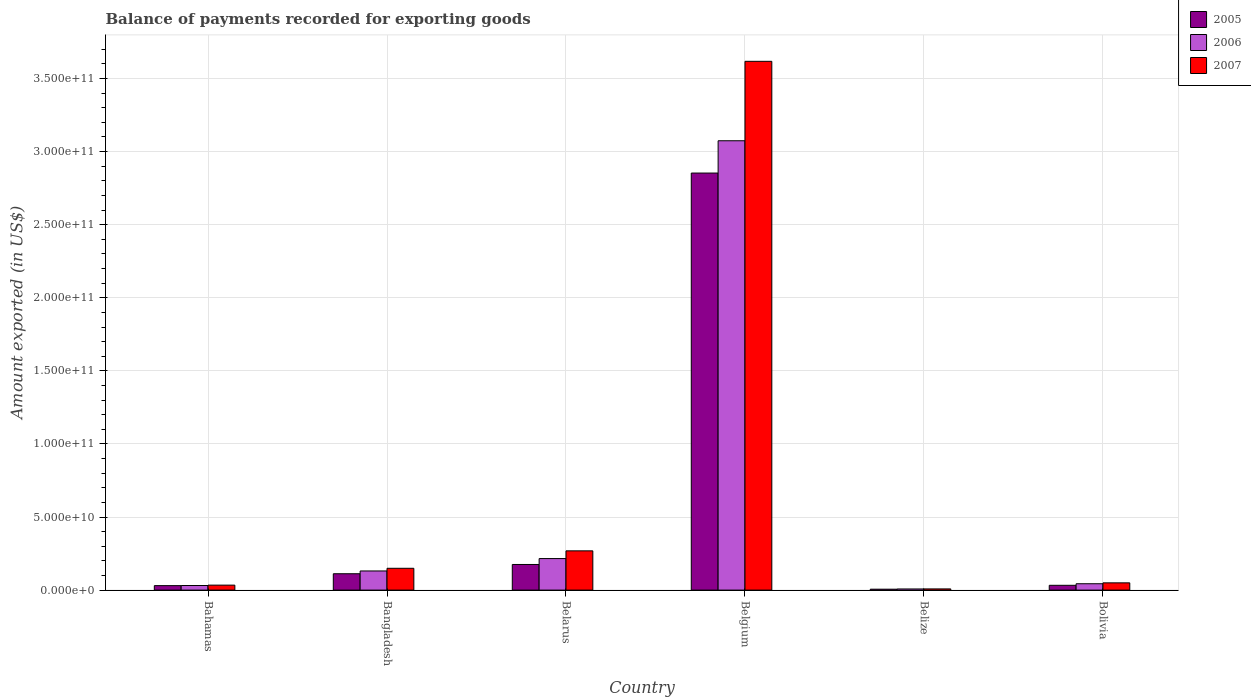How many different coloured bars are there?
Your answer should be very brief. 3. How many groups of bars are there?
Your response must be concise. 6. Are the number of bars per tick equal to the number of legend labels?
Your answer should be very brief. Yes. How many bars are there on the 6th tick from the left?
Ensure brevity in your answer.  3. What is the label of the 4th group of bars from the left?
Your answer should be compact. Belgium. In how many cases, is the number of bars for a given country not equal to the number of legend labels?
Offer a very short reply. 0. What is the amount exported in 2006 in Belize?
Ensure brevity in your answer.  7.76e+08. Across all countries, what is the maximum amount exported in 2007?
Offer a very short reply. 3.62e+11. Across all countries, what is the minimum amount exported in 2005?
Make the answer very short. 6.15e+08. In which country was the amount exported in 2006 maximum?
Offer a terse response. Belgium. In which country was the amount exported in 2006 minimum?
Your answer should be very brief. Belize. What is the total amount exported in 2007 in the graph?
Provide a short and direct response. 4.13e+11. What is the difference between the amount exported in 2005 in Belarus and that in Belgium?
Your answer should be very brief. -2.68e+11. What is the difference between the amount exported in 2006 in Bahamas and the amount exported in 2005 in Belarus?
Provide a succinct answer. -1.44e+1. What is the average amount exported in 2007 per country?
Ensure brevity in your answer.  6.88e+1. What is the difference between the amount exported of/in 2006 and amount exported of/in 2007 in Belgium?
Give a very brief answer. -5.44e+1. What is the ratio of the amount exported in 2006 in Bahamas to that in Belarus?
Your response must be concise. 0.15. What is the difference between the highest and the second highest amount exported in 2006?
Make the answer very short. 2.86e+11. What is the difference between the highest and the lowest amount exported in 2006?
Provide a short and direct response. 3.07e+11. In how many countries, is the amount exported in 2006 greater than the average amount exported in 2006 taken over all countries?
Offer a terse response. 1. Is the sum of the amount exported in 2006 in Belarus and Belize greater than the maximum amount exported in 2007 across all countries?
Provide a short and direct response. No. What does the 3rd bar from the left in Bolivia represents?
Make the answer very short. 2007. Is it the case that in every country, the sum of the amount exported in 2005 and amount exported in 2007 is greater than the amount exported in 2006?
Make the answer very short. Yes. Are all the bars in the graph horizontal?
Ensure brevity in your answer.  No. Are the values on the major ticks of Y-axis written in scientific E-notation?
Your response must be concise. Yes. Where does the legend appear in the graph?
Offer a very short reply. Top right. How many legend labels are there?
Offer a very short reply. 3. How are the legend labels stacked?
Ensure brevity in your answer.  Vertical. What is the title of the graph?
Your response must be concise. Balance of payments recorded for exporting goods. What is the label or title of the Y-axis?
Give a very brief answer. Amount exported (in US$). What is the Amount exported (in US$) in 2005 in Bahamas?
Offer a very short reply. 3.06e+09. What is the Amount exported (in US$) in 2006 in Bahamas?
Offer a terse response. 3.14e+09. What is the Amount exported (in US$) of 2007 in Bahamas?
Your answer should be compact. 3.40e+09. What is the Amount exported (in US$) in 2005 in Bangladesh?
Make the answer very short. 1.12e+1. What is the Amount exported (in US$) of 2006 in Bangladesh?
Provide a succinct answer. 1.31e+1. What is the Amount exported (in US$) of 2007 in Bangladesh?
Make the answer very short. 1.49e+1. What is the Amount exported (in US$) in 2005 in Belarus?
Your answer should be compact. 1.75e+1. What is the Amount exported (in US$) of 2006 in Belarus?
Offer a terse response. 2.16e+1. What is the Amount exported (in US$) of 2007 in Belarus?
Provide a short and direct response. 2.69e+1. What is the Amount exported (in US$) in 2005 in Belgium?
Ensure brevity in your answer.  2.85e+11. What is the Amount exported (in US$) in 2006 in Belgium?
Provide a short and direct response. 3.07e+11. What is the Amount exported (in US$) in 2007 in Belgium?
Offer a terse response. 3.62e+11. What is the Amount exported (in US$) in 2005 in Belize?
Provide a short and direct response. 6.15e+08. What is the Amount exported (in US$) of 2006 in Belize?
Provide a succinct answer. 7.76e+08. What is the Amount exported (in US$) in 2007 in Belize?
Your answer should be very brief. 8.16e+08. What is the Amount exported (in US$) of 2005 in Bolivia?
Provide a short and direct response. 3.28e+09. What is the Amount exported (in US$) of 2006 in Bolivia?
Provide a succinct answer. 4.35e+09. What is the Amount exported (in US$) in 2007 in Bolivia?
Your answer should be compact. 4.95e+09. Across all countries, what is the maximum Amount exported (in US$) of 2005?
Your answer should be compact. 2.85e+11. Across all countries, what is the maximum Amount exported (in US$) of 2006?
Ensure brevity in your answer.  3.07e+11. Across all countries, what is the maximum Amount exported (in US$) of 2007?
Offer a very short reply. 3.62e+11. Across all countries, what is the minimum Amount exported (in US$) of 2005?
Your response must be concise. 6.15e+08. Across all countries, what is the minimum Amount exported (in US$) of 2006?
Make the answer very short. 7.76e+08. Across all countries, what is the minimum Amount exported (in US$) of 2007?
Your answer should be very brief. 8.16e+08. What is the total Amount exported (in US$) in 2005 in the graph?
Keep it short and to the point. 3.21e+11. What is the total Amount exported (in US$) of 2006 in the graph?
Your answer should be compact. 3.50e+11. What is the total Amount exported (in US$) in 2007 in the graph?
Provide a short and direct response. 4.13e+11. What is the difference between the Amount exported (in US$) of 2005 in Bahamas and that in Bangladesh?
Provide a short and direct response. -8.13e+09. What is the difference between the Amount exported (in US$) of 2006 in Bahamas and that in Bangladesh?
Offer a terse response. -9.95e+09. What is the difference between the Amount exported (in US$) in 2007 in Bahamas and that in Bangladesh?
Provide a short and direct response. -1.15e+1. What is the difference between the Amount exported (in US$) of 2005 in Bahamas and that in Belarus?
Your answer should be very brief. -1.45e+1. What is the difference between the Amount exported (in US$) of 2006 in Bahamas and that in Belarus?
Keep it short and to the point. -1.84e+1. What is the difference between the Amount exported (in US$) in 2007 in Bahamas and that in Belarus?
Provide a short and direct response. -2.35e+1. What is the difference between the Amount exported (in US$) of 2005 in Bahamas and that in Belgium?
Your answer should be compact. -2.82e+11. What is the difference between the Amount exported (in US$) in 2006 in Bahamas and that in Belgium?
Keep it short and to the point. -3.04e+11. What is the difference between the Amount exported (in US$) of 2007 in Bahamas and that in Belgium?
Give a very brief answer. -3.58e+11. What is the difference between the Amount exported (in US$) in 2005 in Bahamas and that in Belize?
Your response must be concise. 2.45e+09. What is the difference between the Amount exported (in US$) of 2006 in Bahamas and that in Belize?
Provide a short and direct response. 2.36e+09. What is the difference between the Amount exported (in US$) in 2007 in Bahamas and that in Belize?
Provide a short and direct response. 2.58e+09. What is the difference between the Amount exported (in US$) in 2005 in Bahamas and that in Bolivia?
Keep it short and to the point. -2.19e+08. What is the difference between the Amount exported (in US$) in 2006 in Bahamas and that in Bolivia?
Give a very brief answer. -1.21e+09. What is the difference between the Amount exported (in US$) of 2007 in Bahamas and that in Bolivia?
Your answer should be compact. -1.55e+09. What is the difference between the Amount exported (in US$) of 2005 in Bangladesh and that in Belarus?
Your answer should be very brief. -6.35e+09. What is the difference between the Amount exported (in US$) in 2006 in Bangladesh and that in Belarus?
Provide a succinct answer. -8.48e+09. What is the difference between the Amount exported (in US$) in 2007 in Bangladesh and that in Belarus?
Keep it short and to the point. -1.19e+1. What is the difference between the Amount exported (in US$) of 2005 in Bangladesh and that in Belgium?
Ensure brevity in your answer.  -2.74e+11. What is the difference between the Amount exported (in US$) of 2006 in Bangladesh and that in Belgium?
Offer a very short reply. -2.94e+11. What is the difference between the Amount exported (in US$) of 2007 in Bangladesh and that in Belgium?
Offer a very short reply. -3.47e+11. What is the difference between the Amount exported (in US$) of 2005 in Bangladesh and that in Belize?
Give a very brief answer. 1.06e+1. What is the difference between the Amount exported (in US$) in 2006 in Bangladesh and that in Belize?
Your response must be concise. 1.23e+1. What is the difference between the Amount exported (in US$) of 2007 in Bangladesh and that in Belize?
Provide a succinct answer. 1.41e+1. What is the difference between the Amount exported (in US$) in 2005 in Bangladesh and that in Bolivia?
Your answer should be very brief. 7.91e+09. What is the difference between the Amount exported (in US$) of 2006 in Bangladesh and that in Bolivia?
Keep it short and to the point. 8.74e+09. What is the difference between the Amount exported (in US$) in 2007 in Bangladesh and that in Bolivia?
Your answer should be very brief. 9.97e+09. What is the difference between the Amount exported (in US$) of 2005 in Belarus and that in Belgium?
Keep it short and to the point. -2.68e+11. What is the difference between the Amount exported (in US$) in 2006 in Belarus and that in Belgium?
Ensure brevity in your answer.  -2.86e+11. What is the difference between the Amount exported (in US$) in 2007 in Belarus and that in Belgium?
Provide a succinct answer. -3.35e+11. What is the difference between the Amount exported (in US$) of 2005 in Belarus and that in Belize?
Keep it short and to the point. 1.69e+1. What is the difference between the Amount exported (in US$) in 2006 in Belarus and that in Belize?
Give a very brief answer. 2.08e+1. What is the difference between the Amount exported (in US$) of 2007 in Belarus and that in Belize?
Offer a terse response. 2.60e+1. What is the difference between the Amount exported (in US$) in 2005 in Belarus and that in Bolivia?
Make the answer very short. 1.43e+1. What is the difference between the Amount exported (in US$) of 2006 in Belarus and that in Bolivia?
Give a very brief answer. 1.72e+1. What is the difference between the Amount exported (in US$) of 2007 in Belarus and that in Bolivia?
Your answer should be very brief. 2.19e+1. What is the difference between the Amount exported (in US$) in 2005 in Belgium and that in Belize?
Offer a very short reply. 2.85e+11. What is the difference between the Amount exported (in US$) in 2006 in Belgium and that in Belize?
Provide a succinct answer. 3.07e+11. What is the difference between the Amount exported (in US$) in 2007 in Belgium and that in Belize?
Your answer should be compact. 3.61e+11. What is the difference between the Amount exported (in US$) of 2005 in Belgium and that in Bolivia?
Make the answer very short. 2.82e+11. What is the difference between the Amount exported (in US$) in 2006 in Belgium and that in Bolivia?
Offer a very short reply. 3.03e+11. What is the difference between the Amount exported (in US$) in 2007 in Belgium and that in Bolivia?
Your answer should be very brief. 3.57e+11. What is the difference between the Amount exported (in US$) of 2005 in Belize and that in Bolivia?
Offer a very short reply. -2.66e+09. What is the difference between the Amount exported (in US$) in 2006 in Belize and that in Bolivia?
Offer a terse response. -3.57e+09. What is the difference between the Amount exported (in US$) of 2007 in Belize and that in Bolivia?
Provide a succinct answer. -4.14e+09. What is the difference between the Amount exported (in US$) of 2005 in Bahamas and the Amount exported (in US$) of 2006 in Bangladesh?
Keep it short and to the point. -1.00e+1. What is the difference between the Amount exported (in US$) of 2005 in Bahamas and the Amount exported (in US$) of 2007 in Bangladesh?
Give a very brief answer. -1.19e+1. What is the difference between the Amount exported (in US$) in 2006 in Bahamas and the Amount exported (in US$) in 2007 in Bangladesh?
Your answer should be compact. -1.18e+1. What is the difference between the Amount exported (in US$) in 2005 in Bahamas and the Amount exported (in US$) in 2006 in Belarus?
Provide a short and direct response. -1.85e+1. What is the difference between the Amount exported (in US$) of 2005 in Bahamas and the Amount exported (in US$) of 2007 in Belarus?
Ensure brevity in your answer.  -2.38e+1. What is the difference between the Amount exported (in US$) in 2006 in Bahamas and the Amount exported (in US$) in 2007 in Belarus?
Offer a very short reply. -2.37e+1. What is the difference between the Amount exported (in US$) in 2005 in Bahamas and the Amount exported (in US$) in 2006 in Belgium?
Your answer should be compact. -3.04e+11. What is the difference between the Amount exported (in US$) in 2005 in Bahamas and the Amount exported (in US$) in 2007 in Belgium?
Offer a terse response. -3.59e+11. What is the difference between the Amount exported (in US$) of 2006 in Bahamas and the Amount exported (in US$) of 2007 in Belgium?
Your answer should be very brief. -3.59e+11. What is the difference between the Amount exported (in US$) of 2005 in Bahamas and the Amount exported (in US$) of 2006 in Belize?
Provide a succinct answer. 2.28e+09. What is the difference between the Amount exported (in US$) in 2005 in Bahamas and the Amount exported (in US$) in 2007 in Belize?
Offer a terse response. 2.24e+09. What is the difference between the Amount exported (in US$) in 2006 in Bahamas and the Amount exported (in US$) in 2007 in Belize?
Your response must be concise. 2.32e+09. What is the difference between the Amount exported (in US$) in 2005 in Bahamas and the Amount exported (in US$) in 2006 in Bolivia?
Provide a short and direct response. -1.29e+09. What is the difference between the Amount exported (in US$) of 2005 in Bahamas and the Amount exported (in US$) of 2007 in Bolivia?
Provide a short and direct response. -1.89e+09. What is the difference between the Amount exported (in US$) of 2006 in Bahamas and the Amount exported (in US$) of 2007 in Bolivia?
Make the answer very short. -1.82e+09. What is the difference between the Amount exported (in US$) of 2005 in Bangladesh and the Amount exported (in US$) of 2006 in Belarus?
Offer a very short reply. -1.04e+1. What is the difference between the Amount exported (in US$) in 2005 in Bangladesh and the Amount exported (in US$) in 2007 in Belarus?
Offer a terse response. -1.57e+1. What is the difference between the Amount exported (in US$) of 2006 in Bangladesh and the Amount exported (in US$) of 2007 in Belarus?
Offer a very short reply. -1.38e+1. What is the difference between the Amount exported (in US$) of 2005 in Bangladesh and the Amount exported (in US$) of 2006 in Belgium?
Offer a terse response. -2.96e+11. What is the difference between the Amount exported (in US$) in 2005 in Bangladesh and the Amount exported (in US$) in 2007 in Belgium?
Make the answer very short. -3.51e+11. What is the difference between the Amount exported (in US$) in 2006 in Bangladesh and the Amount exported (in US$) in 2007 in Belgium?
Offer a terse response. -3.49e+11. What is the difference between the Amount exported (in US$) in 2005 in Bangladesh and the Amount exported (in US$) in 2006 in Belize?
Give a very brief answer. 1.04e+1. What is the difference between the Amount exported (in US$) of 2005 in Bangladesh and the Amount exported (in US$) of 2007 in Belize?
Offer a very short reply. 1.04e+1. What is the difference between the Amount exported (in US$) of 2006 in Bangladesh and the Amount exported (in US$) of 2007 in Belize?
Keep it short and to the point. 1.23e+1. What is the difference between the Amount exported (in US$) in 2005 in Bangladesh and the Amount exported (in US$) in 2006 in Bolivia?
Make the answer very short. 6.84e+09. What is the difference between the Amount exported (in US$) of 2005 in Bangladesh and the Amount exported (in US$) of 2007 in Bolivia?
Keep it short and to the point. 6.23e+09. What is the difference between the Amount exported (in US$) of 2006 in Bangladesh and the Amount exported (in US$) of 2007 in Bolivia?
Provide a succinct answer. 8.14e+09. What is the difference between the Amount exported (in US$) in 2005 in Belarus and the Amount exported (in US$) in 2006 in Belgium?
Keep it short and to the point. -2.90e+11. What is the difference between the Amount exported (in US$) in 2005 in Belarus and the Amount exported (in US$) in 2007 in Belgium?
Provide a succinct answer. -3.44e+11. What is the difference between the Amount exported (in US$) of 2006 in Belarus and the Amount exported (in US$) of 2007 in Belgium?
Your response must be concise. -3.40e+11. What is the difference between the Amount exported (in US$) of 2005 in Belarus and the Amount exported (in US$) of 2006 in Belize?
Give a very brief answer. 1.68e+1. What is the difference between the Amount exported (in US$) of 2005 in Belarus and the Amount exported (in US$) of 2007 in Belize?
Offer a terse response. 1.67e+1. What is the difference between the Amount exported (in US$) in 2006 in Belarus and the Amount exported (in US$) in 2007 in Belize?
Provide a succinct answer. 2.08e+1. What is the difference between the Amount exported (in US$) of 2005 in Belarus and the Amount exported (in US$) of 2006 in Bolivia?
Give a very brief answer. 1.32e+1. What is the difference between the Amount exported (in US$) in 2005 in Belarus and the Amount exported (in US$) in 2007 in Bolivia?
Make the answer very short. 1.26e+1. What is the difference between the Amount exported (in US$) of 2006 in Belarus and the Amount exported (in US$) of 2007 in Bolivia?
Make the answer very short. 1.66e+1. What is the difference between the Amount exported (in US$) of 2005 in Belgium and the Amount exported (in US$) of 2006 in Belize?
Offer a very short reply. 2.85e+11. What is the difference between the Amount exported (in US$) of 2005 in Belgium and the Amount exported (in US$) of 2007 in Belize?
Give a very brief answer. 2.85e+11. What is the difference between the Amount exported (in US$) in 2006 in Belgium and the Amount exported (in US$) in 2007 in Belize?
Your answer should be compact. 3.07e+11. What is the difference between the Amount exported (in US$) of 2005 in Belgium and the Amount exported (in US$) of 2006 in Bolivia?
Keep it short and to the point. 2.81e+11. What is the difference between the Amount exported (in US$) of 2005 in Belgium and the Amount exported (in US$) of 2007 in Bolivia?
Make the answer very short. 2.80e+11. What is the difference between the Amount exported (in US$) of 2006 in Belgium and the Amount exported (in US$) of 2007 in Bolivia?
Your answer should be compact. 3.02e+11. What is the difference between the Amount exported (in US$) in 2005 in Belize and the Amount exported (in US$) in 2006 in Bolivia?
Offer a terse response. -3.73e+09. What is the difference between the Amount exported (in US$) of 2005 in Belize and the Amount exported (in US$) of 2007 in Bolivia?
Offer a very short reply. -4.34e+09. What is the difference between the Amount exported (in US$) in 2006 in Belize and the Amount exported (in US$) in 2007 in Bolivia?
Give a very brief answer. -4.18e+09. What is the average Amount exported (in US$) in 2005 per country?
Provide a short and direct response. 5.35e+1. What is the average Amount exported (in US$) of 2006 per country?
Provide a succinct answer. 5.84e+1. What is the average Amount exported (in US$) in 2007 per country?
Make the answer very short. 6.88e+1. What is the difference between the Amount exported (in US$) in 2005 and Amount exported (in US$) in 2006 in Bahamas?
Provide a short and direct response. -7.96e+07. What is the difference between the Amount exported (in US$) of 2005 and Amount exported (in US$) of 2007 in Bahamas?
Ensure brevity in your answer.  -3.41e+08. What is the difference between the Amount exported (in US$) in 2006 and Amount exported (in US$) in 2007 in Bahamas?
Give a very brief answer. -2.62e+08. What is the difference between the Amount exported (in US$) in 2005 and Amount exported (in US$) in 2006 in Bangladesh?
Give a very brief answer. -1.91e+09. What is the difference between the Amount exported (in US$) in 2005 and Amount exported (in US$) in 2007 in Bangladesh?
Ensure brevity in your answer.  -3.74e+09. What is the difference between the Amount exported (in US$) of 2006 and Amount exported (in US$) of 2007 in Bangladesh?
Provide a succinct answer. -1.83e+09. What is the difference between the Amount exported (in US$) of 2005 and Amount exported (in US$) of 2006 in Belarus?
Your answer should be very brief. -4.03e+09. What is the difference between the Amount exported (in US$) in 2005 and Amount exported (in US$) in 2007 in Belarus?
Offer a terse response. -9.32e+09. What is the difference between the Amount exported (in US$) of 2006 and Amount exported (in US$) of 2007 in Belarus?
Offer a terse response. -5.28e+09. What is the difference between the Amount exported (in US$) of 2005 and Amount exported (in US$) of 2006 in Belgium?
Give a very brief answer. -2.21e+1. What is the difference between the Amount exported (in US$) of 2005 and Amount exported (in US$) of 2007 in Belgium?
Ensure brevity in your answer.  -7.65e+1. What is the difference between the Amount exported (in US$) in 2006 and Amount exported (in US$) in 2007 in Belgium?
Keep it short and to the point. -5.44e+1. What is the difference between the Amount exported (in US$) in 2005 and Amount exported (in US$) in 2006 in Belize?
Offer a terse response. -1.61e+08. What is the difference between the Amount exported (in US$) of 2005 and Amount exported (in US$) of 2007 in Belize?
Your answer should be compact. -2.01e+08. What is the difference between the Amount exported (in US$) in 2006 and Amount exported (in US$) in 2007 in Belize?
Provide a succinct answer. -4.04e+07. What is the difference between the Amount exported (in US$) of 2005 and Amount exported (in US$) of 2006 in Bolivia?
Ensure brevity in your answer.  -1.07e+09. What is the difference between the Amount exported (in US$) of 2005 and Amount exported (in US$) of 2007 in Bolivia?
Make the answer very short. -1.68e+09. What is the difference between the Amount exported (in US$) of 2006 and Amount exported (in US$) of 2007 in Bolivia?
Your response must be concise. -6.05e+08. What is the ratio of the Amount exported (in US$) in 2005 in Bahamas to that in Bangladesh?
Your answer should be compact. 0.27. What is the ratio of the Amount exported (in US$) of 2006 in Bahamas to that in Bangladesh?
Offer a very short reply. 0.24. What is the ratio of the Amount exported (in US$) in 2007 in Bahamas to that in Bangladesh?
Offer a terse response. 0.23. What is the ratio of the Amount exported (in US$) of 2005 in Bahamas to that in Belarus?
Offer a terse response. 0.17. What is the ratio of the Amount exported (in US$) in 2006 in Bahamas to that in Belarus?
Keep it short and to the point. 0.15. What is the ratio of the Amount exported (in US$) of 2007 in Bahamas to that in Belarus?
Give a very brief answer. 0.13. What is the ratio of the Amount exported (in US$) in 2005 in Bahamas to that in Belgium?
Keep it short and to the point. 0.01. What is the ratio of the Amount exported (in US$) in 2006 in Bahamas to that in Belgium?
Your answer should be very brief. 0.01. What is the ratio of the Amount exported (in US$) in 2007 in Bahamas to that in Belgium?
Your answer should be compact. 0.01. What is the ratio of the Amount exported (in US$) in 2005 in Bahamas to that in Belize?
Your answer should be compact. 4.98. What is the ratio of the Amount exported (in US$) of 2006 in Bahamas to that in Belize?
Your answer should be compact. 4.05. What is the ratio of the Amount exported (in US$) of 2007 in Bahamas to that in Belize?
Your answer should be very brief. 4.17. What is the ratio of the Amount exported (in US$) of 2005 in Bahamas to that in Bolivia?
Offer a terse response. 0.93. What is the ratio of the Amount exported (in US$) in 2006 in Bahamas to that in Bolivia?
Offer a terse response. 0.72. What is the ratio of the Amount exported (in US$) in 2007 in Bahamas to that in Bolivia?
Your answer should be compact. 0.69. What is the ratio of the Amount exported (in US$) in 2005 in Bangladesh to that in Belarus?
Keep it short and to the point. 0.64. What is the ratio of the Amount exported (in US$) in 2006 in Bangladesh to that in Belarus?
Make the answer very short. 0.61. What is the ratio of the Amount exported (in US$) of 2007 in Bangladesh to that in Belarus?
Your answer should be compact. 0.56. What is the ratio of the Amount exported (in US$) of 2005 in Bangladesh to that in Belgium?
Your answer should be compact. 0.04. What is the ratio of the Amount exported (in US$) of 2006 in Bangladesh to that in Belgium?
Offer a very short reply. 0.04. What is the ratio of the Amount exported (in US$) in 2007 in Bangladesh to that in Belgium?
Offer a very short reply. 0.04. What is the ratio of the Amount exported (in US$) in 2005 in Bangladesh to that in Belize?
Provide a short and direct response. 18.19. What is the ratio of the Amount exported (in US$) of 2006 in Bangladesh to that in Belize?
Offer a very short reply. 16.87. What is the ratio of the Amount exported (in US$) of 2007 in Bangladesh to that in Belize?
Provide a short and direct response. 18.28. What is the ratio of the Amount exported (in US$) of 2005 in Bangladesh to that in Bolivia?
Offer a very short reply. 3.41. What is the ratio of the Amount exported (in US$) of 2006 in Bangladesh to that in Bolivia?
Offer a very short reply. 3.01. What is the ratio of the Amount exported (in US$) in 2007 in Bangladesh to that in Bolivia?
Your answer should be very brief. 3.01. What is the ratio of the Amount exported (in US$) of 2005 in Belarus to that in Belgium?
Your answer should be compact. 0.06. What is the ratio of the Amount exported (in US$) in 2006 in Belarus to that in Belgium?
Keep it short and to the point. 0.07. What is the ratio of the Amount exported (in US$) of 2007 in Belarus to that in Belgium?
Offer a very short reply. 0.07. What is the ratio of the Amount exported (in US$) in 2005 in Belarus to that in Belize?
Keep it short and to the point. 28.51. What is the ratio of the Amount exported (in US$) in 2006 in Belarus to that in Belize?
Your answer should be compact. 27.8. What is the ratio of the Amount exported (in US$) in 2007 in Belarus to that in Belize?
Ensure brevity in your answer.  32.89. What is the ratio of the Amount exported (in US$) in 2005 in Belarus to that in Bolivia?
Your answer should be compact. 5.35. What is the ratio of the Amount exported (in US$) in 2006 in Belarus to that in Bolivia?
Provide a succinct answer. 4.96. What is the ratio of the Amount exported (in US$) of 2007 in Belarus to that in Bolivia?
Provide a succinct answer. 5.42. What is the ratio of the Amount exported (in US$) in 2005 in Belgium to that in Belize?
Your answer should be very brief. 463.93. What is the ratio of the Amount exported (in US$) in 2006 in Belgium to that in Belize?
Make the answer very short. 396.18. What is the ratio of the Amount exported (in US$) in 2007 in Belgium to that in Belize?
Offer a terse response. 443.16. What is the ratio of the Amount exported (in US$) in 2005 in Belgium to that in Bolivia?
Your answer should be very brief. 87. What is the ratio of the Amount exported (in US$) in 2006 in Belgium to that in Bolivia?
Provide a succinct answer. 70.68. What is the ratio of the Amount exported (in US$) in 2007 in Belgium to that in Bolivia?
Give a very brief answer. 73.02. What is the ratio of the Amount exported (in US$) of 2005 in Belize to that in Bolivia?
Make the answer very short. 0.19. What is the ratio of the Amount exported (in US$) in 2006 in Belize to that in Bolivia?
Keep it short and to the point. 0.18. What is the ratio of the Amount exported (in US$) in 2007 in Belize to that in Bolivia?
Your answer should be very brief. 0.16. What is the difference between the highest and the second highest Amount exported (in US$) in 2005?
Provide a short and direct response. 2.68e+11. What is the difference between the highest and the second highest Amount exported (in US$) in 2006?
Make the answer very short. 2.86e+11. What is the difference between the highest and the second highest Amount exported (in US$) in 2007?
Your answer should be very brief. 3.35e+11. What is the difference between the highest and the lowest Amount exported (in US$) in 2005?
Offer a terse response. 2.85e+11. What is the difference between the highest and the lowest Amount exported (in US$) of 2006?
Your answer should be compact. 3.07e+11. What is the difference between the highest and the lowest Amount exported (in US$) in 2007?
Give a very brief answer. 3.61e+11. 